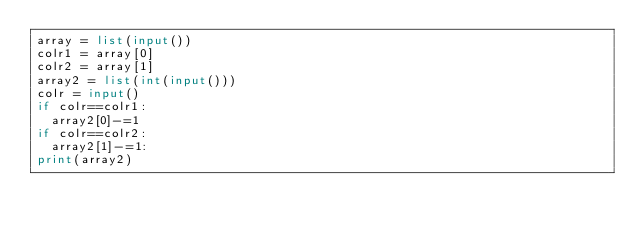Convert code to text. <code><loc_0><loc_0><loc_500><loc_500><_Python_>array = list(input())
colr1 = array[0]
colr2 = array[1]
array2 = list(int(input()))
colr = input()
if colr==colr1:
  array2[0]-=1
if colr==colr2:
  array2[1]-=1:
print(array2)</code> 